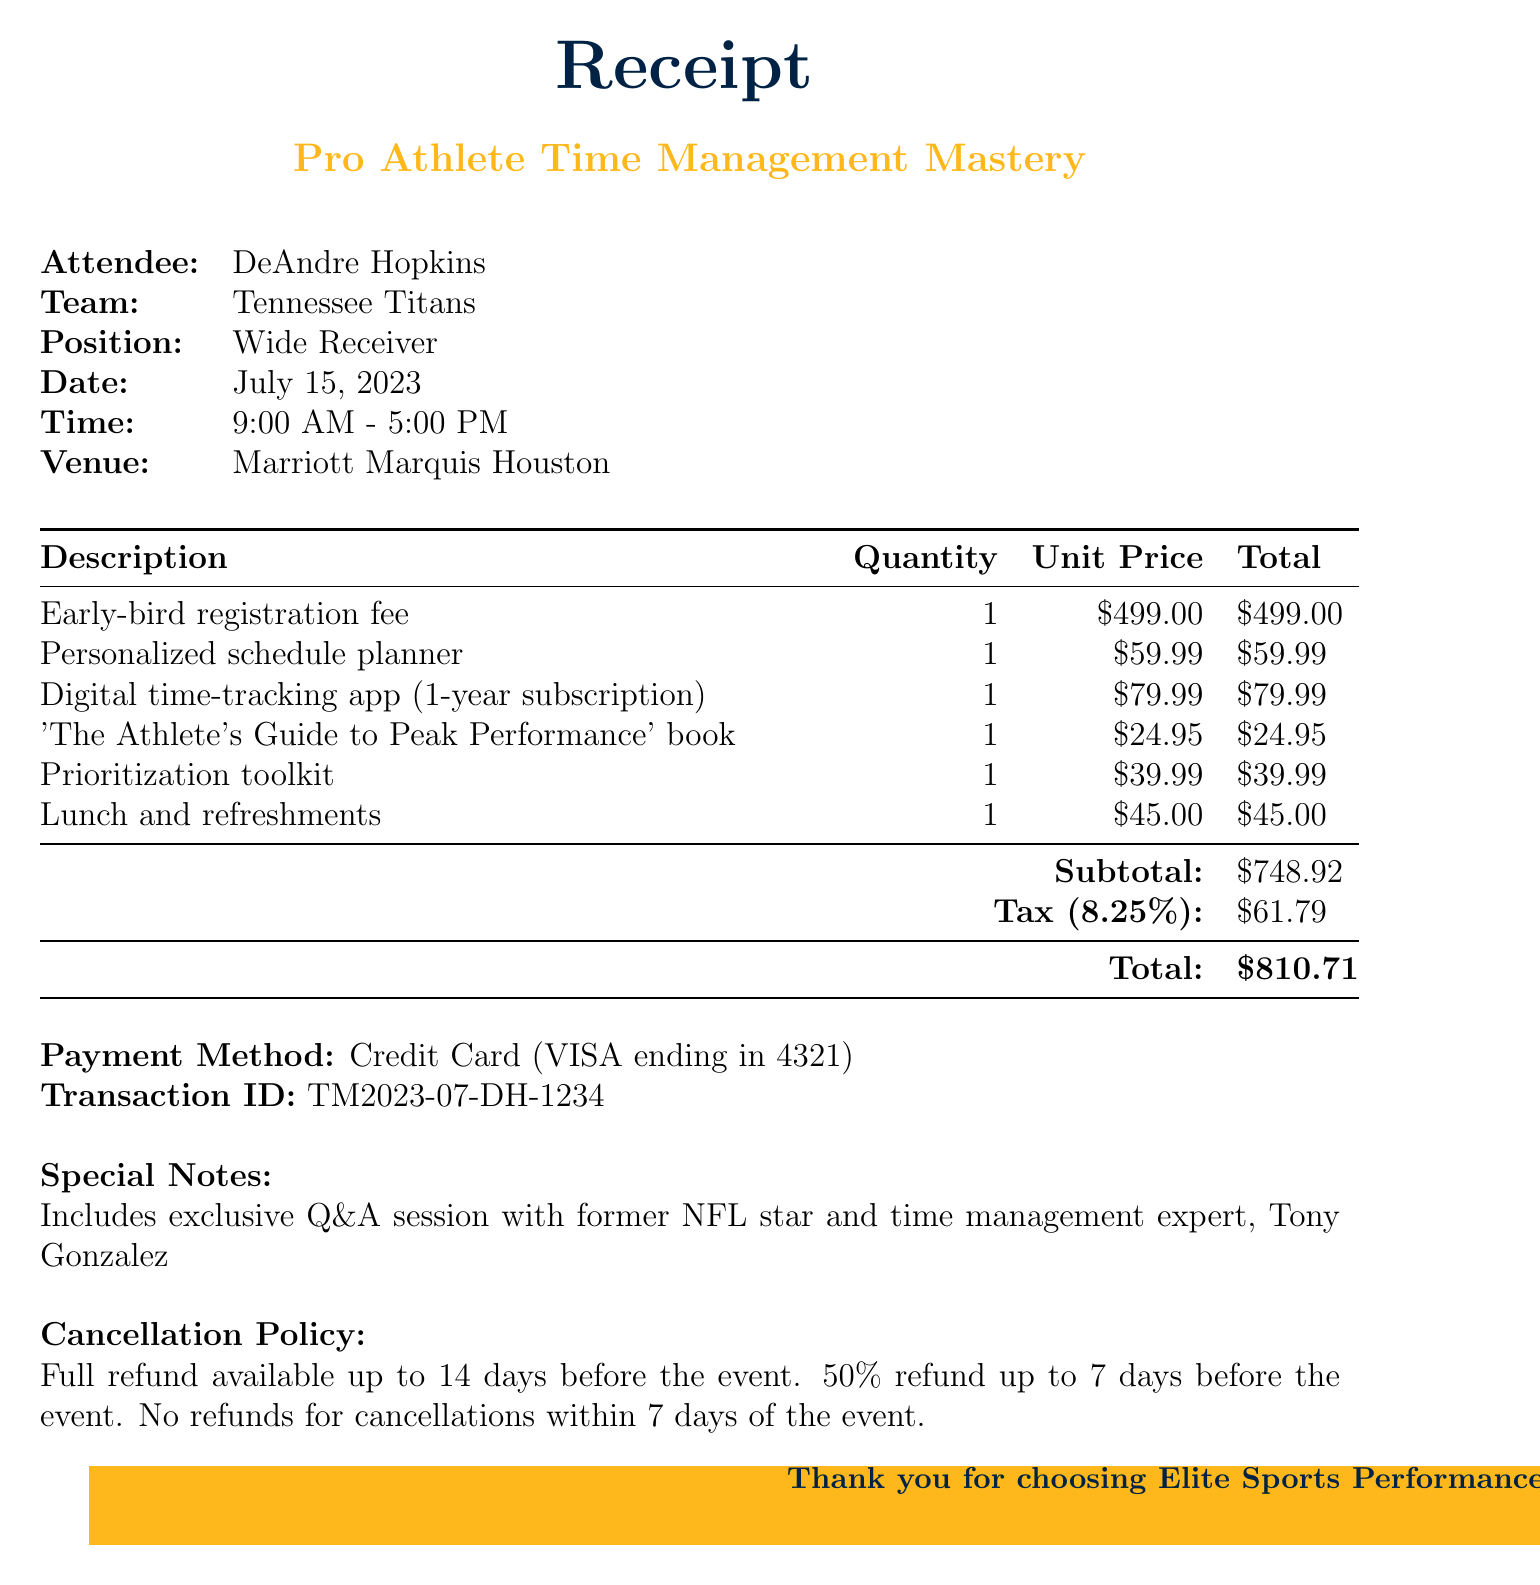What is the workshop name? The workshop name is listed at the top of the receipt.
Answer: Pro Athlete Time Management Mastery What is the total amount due? The total amount due is indicated at the end of the line item summary.
Answer: $810.71 What is the date of the event? The date is provided in a clear format under the attendee's details.
Answer: July 15, 2023 What is the name of the attendee? The name of the attendee is mentioned in the attendee section.
Answer: DeAndre Hopkins What is the tax rate applied? The tax rate is mentioned next to the tax amount in the summary.
Answer: 8.25% What is included in the cancellation policy? This describes the refund conditions expressed in the document.
Answer: Full refund available up to 14 days before the event How many line items are on the receipt? The number of line items can be counted from the description of services provided.
Answer: 6 What is the venue for the workshop? The venue is specified in the details section of the receipt.
Answer: Marriott Marquis Houston What special note is included in the receipt? The special note provides context on additional benefits of the workshop.
Answer: Includes exclusive Q&A session with former NFL star and time management expert, Tony Gonzalez 